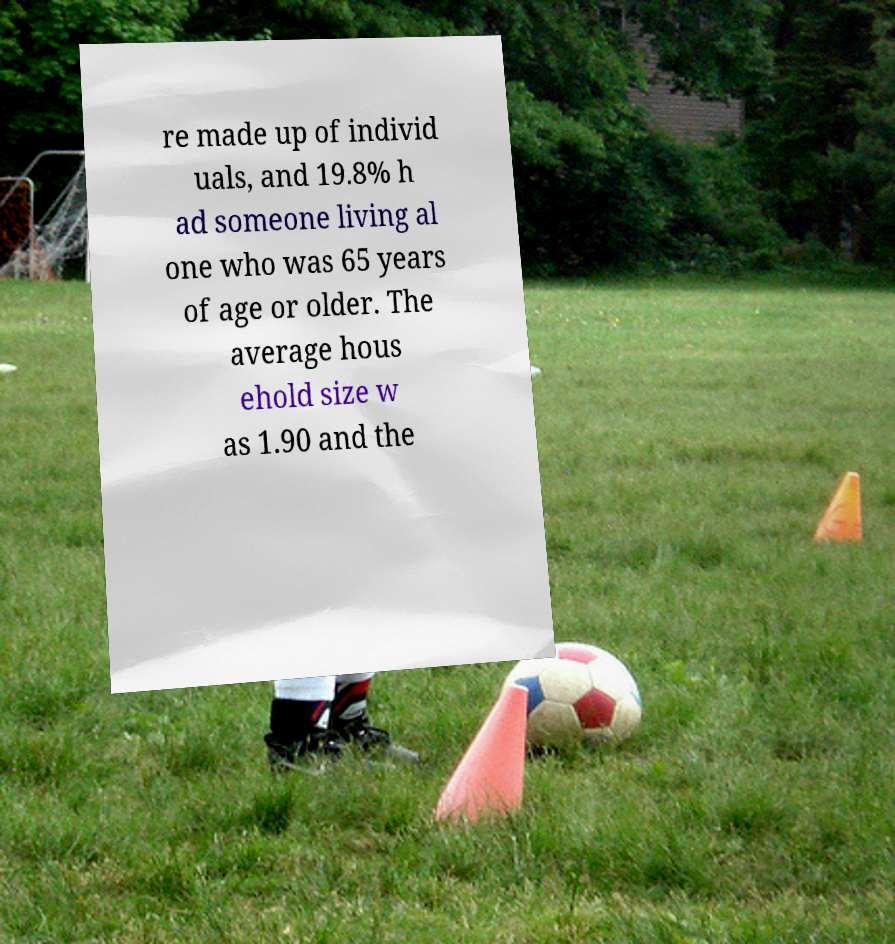There's text embedded in this image that I need extracted. Can you transcribe it verbatim? re made up of individ uals, and 19.8% h ad someone living al one who was 65 years of age or older. The average hous ehold size w as 1.90 and the 